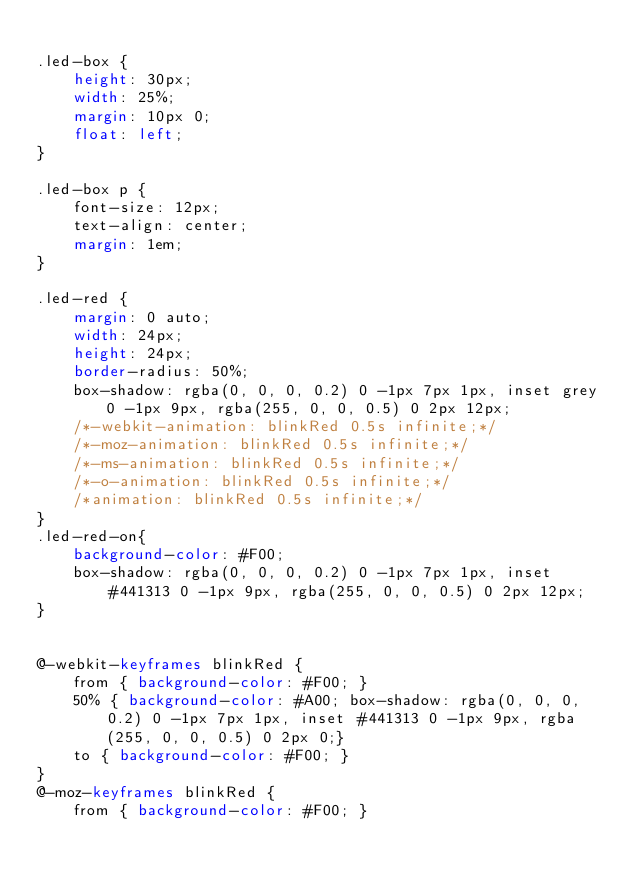Convert code to text. <code><loc_0><loc_0><loc_500><loc_500><_CSS_>
.led-box {
    height: 30px;
    width: 25%;
    margin: 10px 0;
    float: left;
}

.led-box p {
    font-size: 12px;
    text-align: center;
    margin: 1em;
}

.led-red {
    margin: 0 auto;
    width: 24px;
    height: 24px;
    border-radius: 50%;
    box-shadow: rgba(0, 0, 0, 0.2) 0 -1px 7px 1px, inset grey 0 -1px 9px, rgba(255, 0, 0, 0.5) 0 2px 12px;
    /*-webkit-animation: blinkRed 0.5s infinite;*/
    /*-moz-animation: blinkRed 0.5s infinite;*/
    /*-ms-animation: blinkRed 0.5s infinite;*/
    /*-o-animation: blinkRed 0.5s infinite;*/
    /*animation: blinkRed 0.5s infinite;*/
}
.led-red-on{
    background-color: #F00;
    box-shadow: rgba(0, 0, 0, 0.2) 0 -1px 7px 1px, inset #441313 0 -1px 9px, rgba(255, 0, 0, 0.5) 0 2px 12px;
}


@-webkit-keyframes blinkRed {
    from { background-color: #F00; }
    50% { background-color: #A00; box-shadow: rgba(0, 0, 0, 0.2) 0 -1px 7px 1px, inset #441313 0 -1px 9px, rgba(255, 0, 0, 0.5) 0 2px 0;}
    to { background-color: #F00; }
}
@-moz-keyframes blinkRed {
    from { background-color: #F00; }</code> 